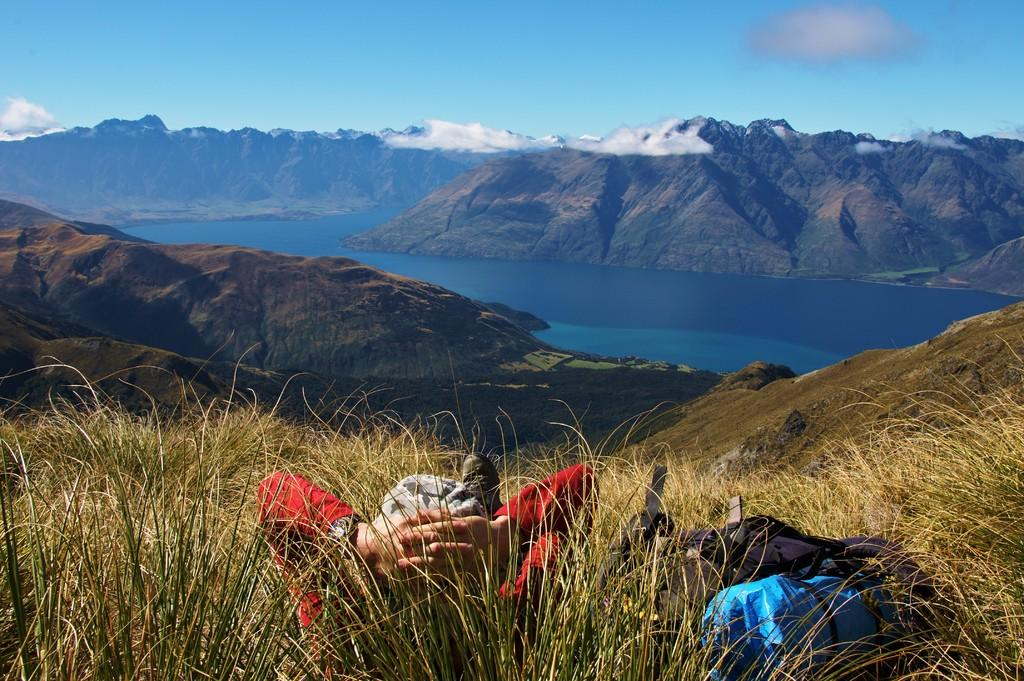What is the person in the image doing? There is a person laying on the grass in the image. What else can be seen in the image besides the person? There are bags and water visible in the image. What is the background of the image? Mountains are present in the background of the image, and the sky is visible as well. Can you describe the sky in the image? The sky is visible in the background of the image, and clouds are present. What type of acoustics can be heard in the image? There is no information about sounds or acoustics in the image, so it cannot be determined. What toys are visible in the image? There are no toys present in the image. 